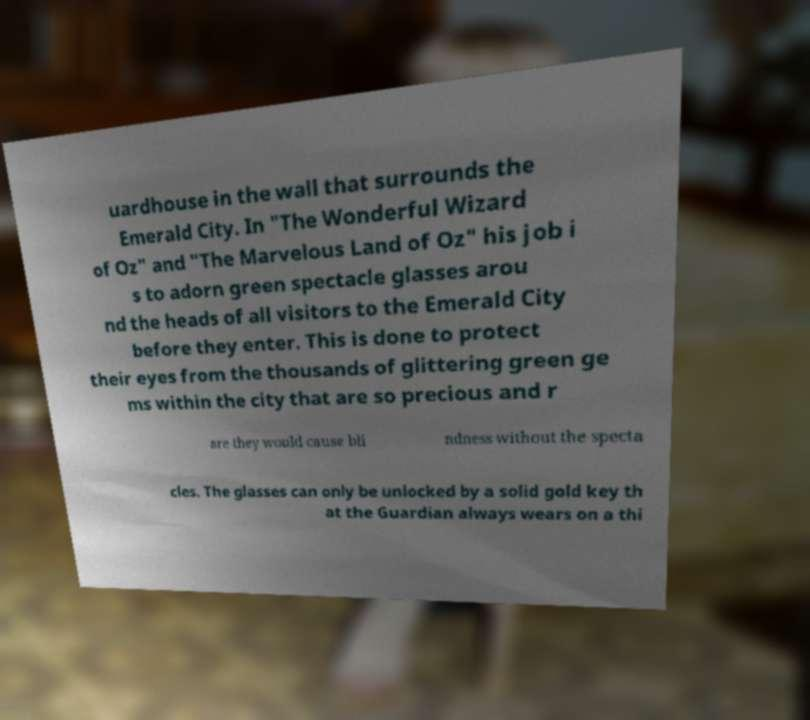There's text embedded in this image that I need extracted. Can you transcribe it verbatim? uardhouse in the wall that surrounds the Emerald City. In "The Wonderful Wizard of Oz" and "The Marvelous Land of Oz" his job i s to adorn green spectacle glasses arou nd the heads of all visitors to the Emerald City before they enter. This is done to protect their eyes from the thousands of glittering green ge ms within the city that are so precious and r are they would cause bli ndness without the specta cles. The glasses can only be unlocked by a solid gold key th at the Guardian always wears on a thi 